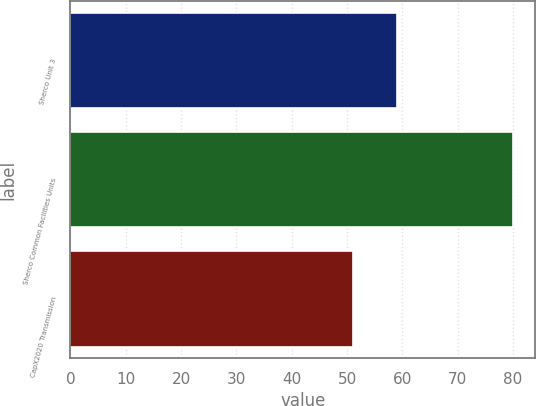<chart> <loc_0><loc_0><loc_500><loc_500><bar_chart><fcel>Sherco Unit 3<fcel>Sherco Common Facilities Units<fcel>CapX2020 Transmission<nl><fcel>59<fcel>80<fcel>51<nl></chart> 